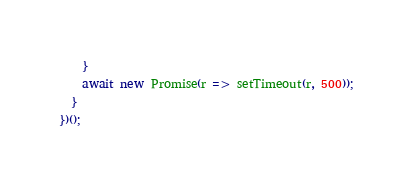Convert code to text. <code><loc_0><loc_0><loc_500><loc_500><_JavaScript_>    }
    await new Promise(r => setTimeout(r, 500));
  }
})();
</code> 